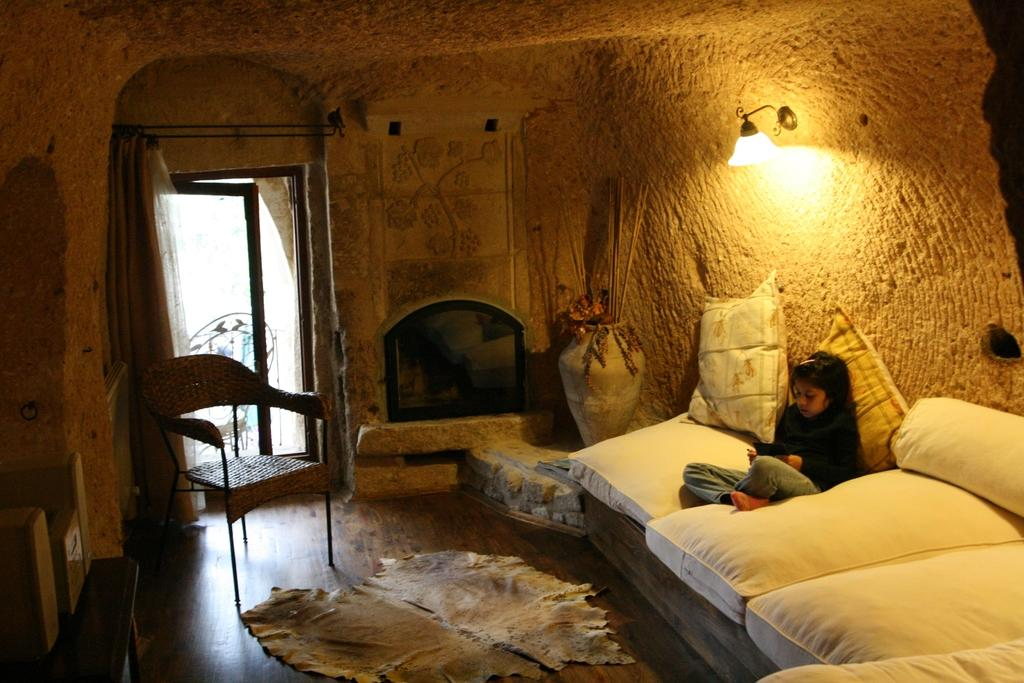What type of space is depicted in the image? There is a room in the image. What piece of furniture is present in the room? There is a bed in the room. What is the person in the image doing? A person is sitting on the bed and holding something. Are there any other pieces of furniture in the room? Yes, there is a chair in the room. What type of lighting is available in the room? There is a lamp in the room. What other objects can be seen in the room? There is a pot and a curtain in the room. What is the texture of the roll on the bed in the image? There is no roll present on the bed in the image. 